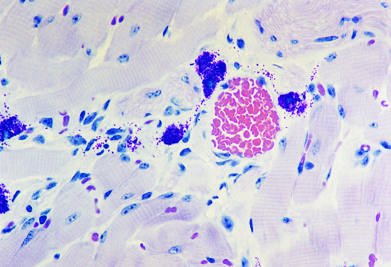s the immediate reaction characterized by an inflammatory infiltrate rich in eosinophils, neutrophils, and t cells?
Answer the question using a single word or phrase. No 